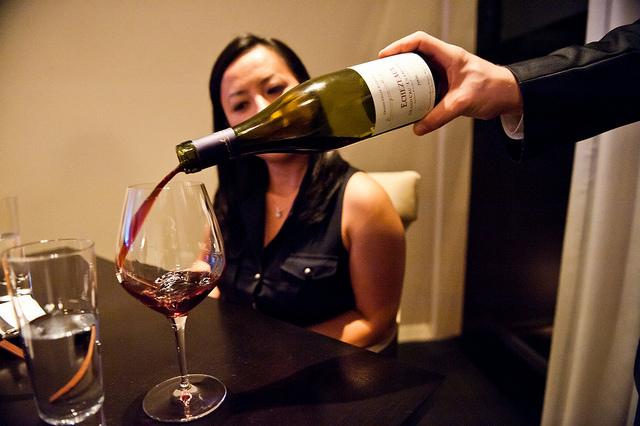How many glasses of water are in the picture?
Quick response, please. 1. Is someone pouring wine?
Short answer required. Yes. Is the wine glass empty?
Keep it brief. No. What part of the bottle is the man holding to pour it?
Write a very short answer. Bottom. 